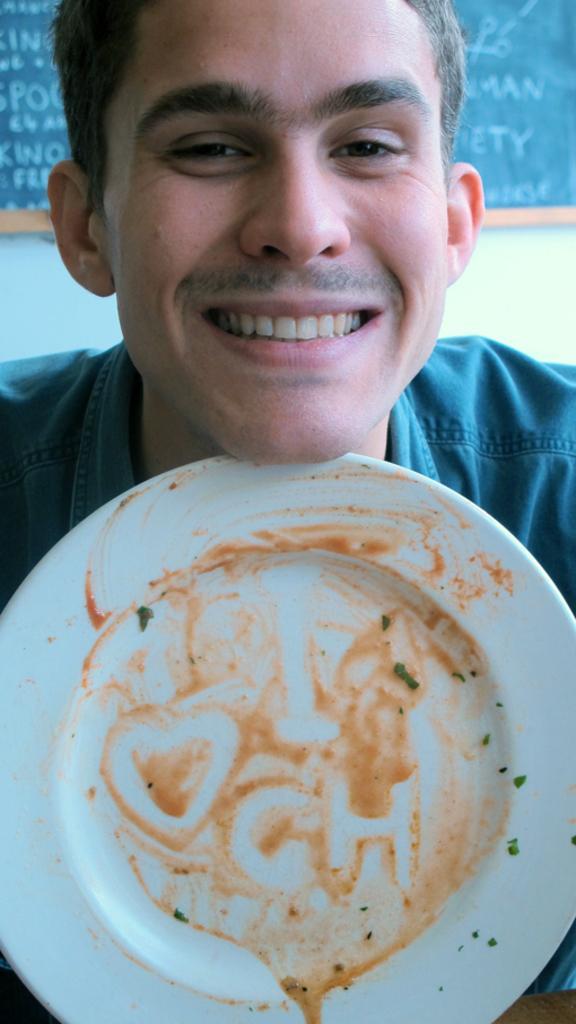Can you describe this image briefly? In this picture we can see a plate and a man smiling and in the background we can see a board on the wall. 